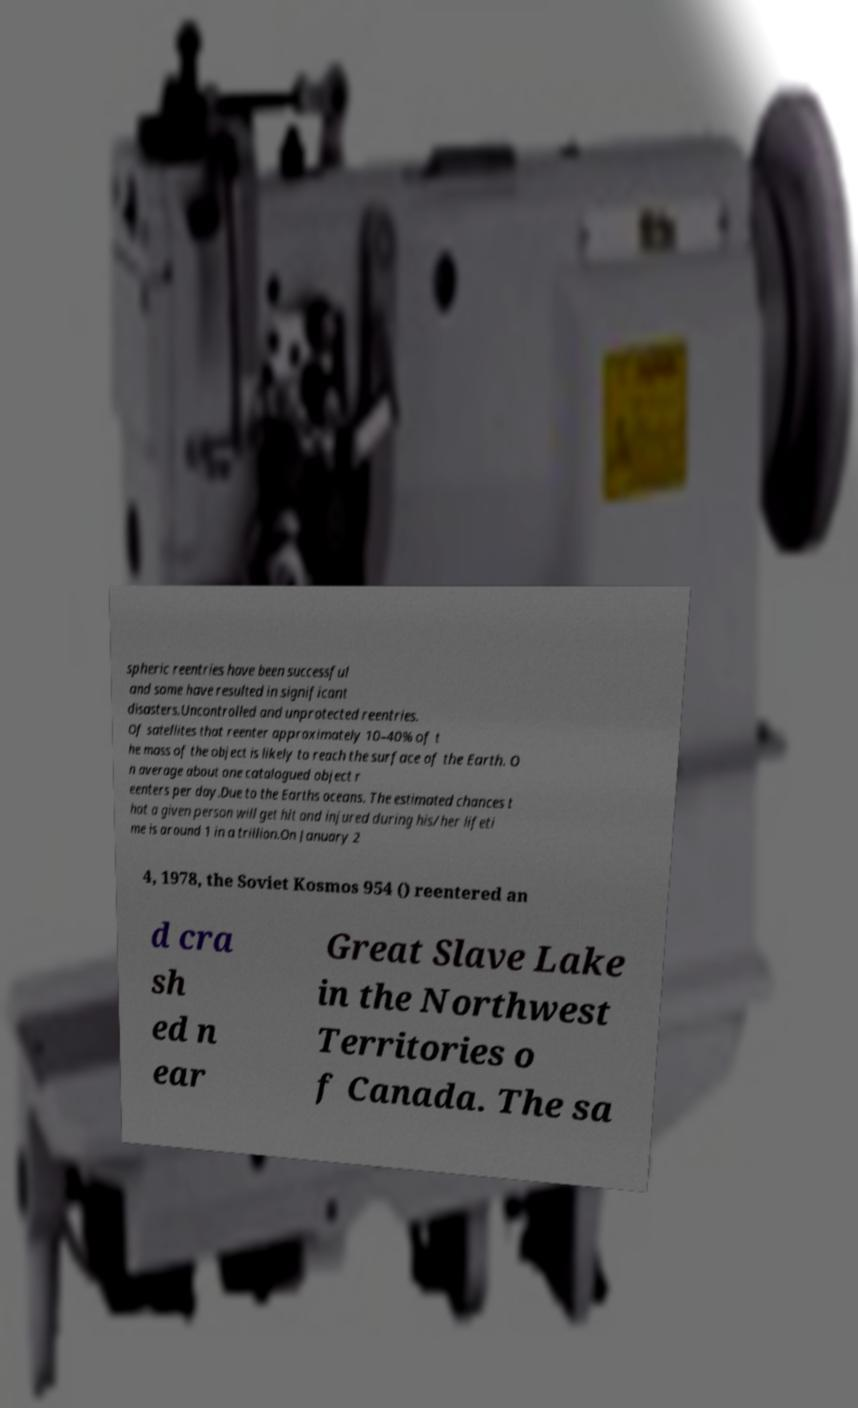What messages or text are displayed in this image? I need them in a readable, typed format. spheric reentries have been successful and some have resulted in significant disasters.Uncontrolled and unprotected reentries. Of satellites that reenter approximately 10–40% of t he mass of the object is likely to reach the surface of the Earth. O n average about one catalogued object r eenters per day.Due to the Earths oceans. The estimated chances t hat a given person will get hit and injured during his/her lifeti me is around 1 in a trillion.On January 2 4, 1978, the Soviet Kosmos 954 () reentered an d cra sh ed n ear Great Slave Lake in the Northwest Territories o f Canada. The sa 